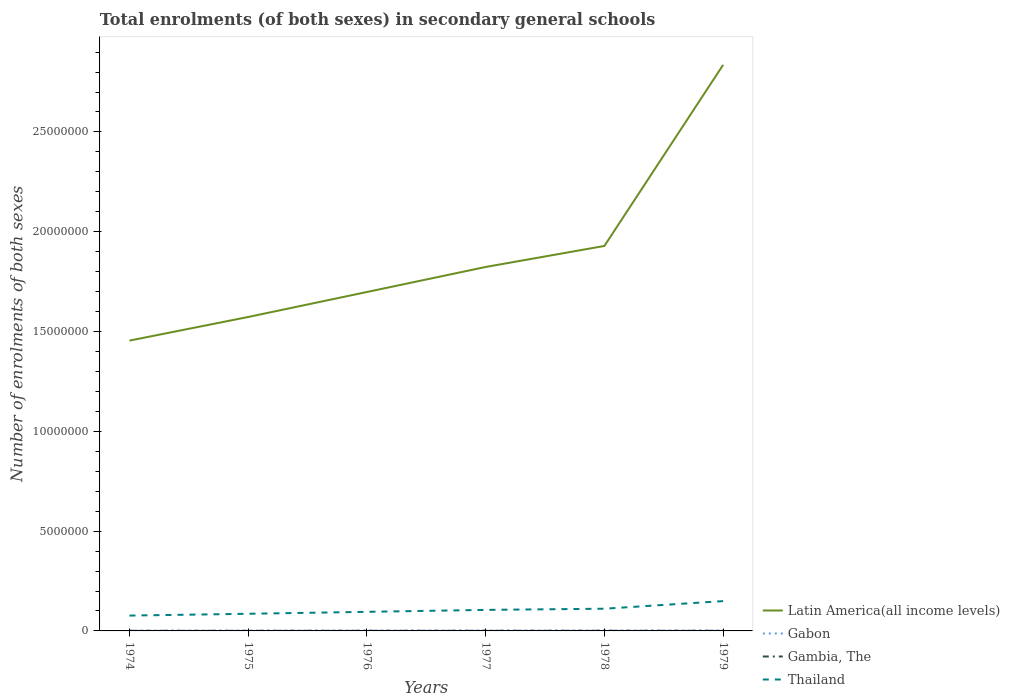Does the line corresponding to Gambia, The intersect with the line corresponding to Thailand?
Ensure brevity in your answer.  No. Is the number of lines equal to the number of legend labels?
Your answer should be compact. Yes. Across all years, what is the maximum number of enrolments in secondary schools in Gabon?
Make the answer very short. 1.45e+04. In which year was the number of enrolments in secondary schools in Gambia, The maximum?
Ensure brevity in your answer.  1974. What is the total number of enrolments in secondary schools in Thailand in the graph?
Your answer should be compact. -3.44e+05. What is the difference between the highest and the second highest number of enrolments in secondary schools in Gambia, The?
Your answer should be compact. 1870. How many lines are there?
Keep it short and to the point. 4. How many years are there in the graph?
Provide a succinct answer. 6. Are the values on the major ticks of Y-axis written in scientific E-notation?
Offer a very short reply. No. Does the graph contain grids?
Offer a terse response. No. Where does the legend appear in the graph?
Offer a terse response. Bottom right. How are the legend labels stacked?
Your response must be concise. Vertical. What is the title of the graph?
Offer a very short reply. Total enrolments (of both sexes) in secondary general schools. Does "Heavily indebted poor countries" appear as one of the legend labels in the graph?
Ensure brevity in your answer.  No. What is the label or title of the Y-axis?
Ensure brevity in your answer.  Number of enrolments of both sexes. What is the Number of enrolments of both sexes in Latin America(all income levels) in 1974?
Give a very brief answer. 1.45e+07. What is the Number of enrolments of both sexes in Gabon in 1974?
Keep it short and to the point. 1.45e+04. What is the Number of enrolments of both sexes of Gambia, The in 1974?
Provide a succinct answer. 5614. What is the Number of enrolments of both sexes of Thailand in 1974?
Ensure brevity in your answer.  7.69e+05. What is the Number of enrolments of both sexes of Latin America(all income levels) in 1975?
Offer a very short reply. 1.57e+07. What is the Number of enrolments of both sexes of Gabon in 1975?
Provide a succinct answer. 1.76e+04. What is the Number of enrolments of both sexes of Gambia, The in 1975?
Keep it short and to the point. 5791. What is the Number of enrolments of both sexes in Thailand in 1975?
Offer a very short reply. 8.59e+05. What is the Number of enrolments of both sexes in Latin America(all income levels) in 1976?
Give a very brief answer. 1.70e+07. What is the Number of enrolments of both sexes in Gabon in 1976?
Provide a succinct answer. 1.97e+04. What is the Number of enrolments of both sexes of Gambia, The in 1976?
Provide a short and direct response. 6178. What is the Number of enrolments of both sexes of Thailand in 1976?
Make the answer very short. 9.56e+05. What is the Number of enrolments of both sexes in Latin America(all income levels) in 1977?
Ensure brevity in your answer.  1.82e+07. What is the Number of enrolments of both sexes in Gabon in 1977?
Keep it short and to the point. 2.04e+04. What is the Number of enrolments of both sexes in Gambia, The in 1977?
Ensure brevity in your answer.  6834. What is the Number of enrolments of both sexes of Thailand in 1977?
Give a very brief answer. 1.05e+06. What is the Number of enrolments of both sexes in Latin America(all income levels) in 1978?
Your response must be concise. 1.93e+07. What is the Number of enrolments of both sexes of Gabon in 1978?
Provide a short and direct response. 2.16e+04. What is the Number of enrolments of both sexes of Gambia, The in 1978?
Make the answer very short. 6994. What is the Number of enrolments of both sexes of Thailand in 1978?
Ensure brevity in your answer.  1.11e+06. What is the Number of enrolments of both sexes of Latin America(all income levels) in 1979?
Make the answer very short. 2.84e+07. What is the Number of enrolments of both sexes in Gabon in 1979?
Keep it short and to the point. 2.03e+04. What is the Number of enrolments of both sexes of Gambia, The in 1979?
Provide a short and direct response. 7484. What is the Number of enrolments of both sexes in Thailand in 1979?
Offer a very short reply. 1.49e+06. Across all years, what is the maximum Number of enrolments of both sexes in Latin America(all income levels)?
Provide a short and direct response. 2.84e+07. Across all years, what is the maximum Number of enrolments of both sexes in Gabon?
Your answer should be compact. 2.16e+04. Across all years, what is the maximum Number of enrolments of both sexes of Gambia, The?
Your answer should be very brief. 7484. Across all years, what is the maximum Number of enrolments of both sexes in Thailand?
Your answer should be very brief. 1.49e+06. Across all years, what is the minimum Number of enrolments of both sexes in Latin America(all income levels)?
Ensure brevity in your answer.  1.45e+07. Across all years, what is the minimum Number of enrolments of both sexes in Gabon?
Ensure brevity in your answer.  1.45e+04. Across all years, what is the minimum Number of enrolments of both sexes of Gambia, The?
Keep it short and to the point. 5614. Across all years, what is the minimum Number of enrolments of both sexes in Thailand?
Keep it short and to the point. 7.69e+05. What is the total Number of enrolments of both sexes of Latin America(all income levels) in the graph?
Your answer should be very brief. 1.13e+08. What is the total Number of enrolments of both sexes in Gabon in the graph?
Your response must be concise. 1.14e+05. What is the total Number of enrolments of both sexes in Gambia, The in the graph?
Keep it short and to the point. 3.89e+04. What is the total Number of enrolments of both sexes of Thailand in the graph?
Your answer should be compact. 6.24e+06. What is the difference between the Number of enrolments of both sexes in Latin America(all income levels) in 1974 and that in 1975?
Provide a short and direct response. -1.18e+06. What is the difference between the Number of enrolments of both sexes of Gabon in 1974 and that in 1975?
Keep it short and to the point. -3085. What is the difference between the Number of enrolments of both sexes of Gambia, The in 1974 and that in 1975?
Your response must be concise. -177. What is the difference between the Number of enrolments of both sexes in Thailand in 1974 and that in 1975?
Your response must be concise. -9.01e+04. What is the difference between the Number of enrolments of both sexes of Latin America(all income levels) in 1974 and that in 1976?
Provide a succinct answer. -2.44e+06. What is the difference between the Number of enrolments of both sexes of Gabon in 1974 and that in 1976?
Ensure brevity in your answer.  -5231. What is the difference between the Number of enrolments of both sexes of Gambia, The in 1974 and that in 1976?
Keep it short and to the point. -564. What is the difference between the Number of enrolments of both sexes in Thailand in 1974 and that in 1976?
Keep it short and to the point. -1.88e+05. What is the difference between the Number of enrolments of both sexes in Latin America(all income levels) in 1974 and that in 1977?
Your answer should be very brief. -3.69e+06. What is the difference between the Number of enrolments of both sexes of Gabon in 1974 and that in 1977?
Provide a succinct answer. -5877. What is the difference between the Number of enrolments of both sexes of Gambia, The in 1974 and that in 1977?
Your answer should be very brief. -1220. What is the difference between the Number of enrolments of both sexes in Thailand in 1974 and that in 1977?
Your answer should be very brief. -2.85e+05. What is the difference between the Number of enrolments of both sexes in Latin America(all income levels) in 1974 and that in 1978?
Your answer should be very brief. -4.74e+06. What is the difference between the Number of enrolments of both sexes of Gabon in 1974 and that in 1978?
Provide a succinct answer. -7124. What is the difference between the Number of enrolments of both sexes of Gambia, The in 1974 and that in 1978?
Offer a terse response. -1380. What is the difference between the Number of enrolments of both sexes of Thailand in 1974 and that in 1978?
Ensure brevity in your answer.  -3.44e+05. What is the difference between the Number of enrolments of both sexes in Latin America(all income levels) in 1974 and that in 1979?
Offer a terse response. -1.38e+07. What is the difference between the Number of enrolments of both sexes of Gabon in 1974 and that in 1979?
Give a very brief answer. -5854. What is the difference between the Number of enrolments of both sexes in Gambia, The in 1974 and that in 1979?
Offer a terse response. -1870. What is the difference between the Number of enrolments of both sexes of Thailand in 1974 and that in 1979?
Your answer should be compact. -7.25e+05. What is the difference between the Number of enrolments of both sexes in Latin America(all income levels) in 1975 and that in 1976?
Your answer should be compact. -1.25e+06. What is the difference between the Number of enrolments of both sexes of Gabon in 1975 and that in 1976?
Provide a succinct answer. -2146. What is the difference between the Number of enrolments of both sexes of Gambia, The in 1975 and that in 1976?
Your response must be concise. -387. What is the difference between the Number of enrolments of both sexes of Thailand in 1975 and that in 1976?
Ensure brevity in your answer.  -9.75e+04. What is the difference between the Number of enrolments of both sexes of Latin America(all income levels) in 1975 and that in 1977?
Provide a succinct answer. -2.51e+06. What is the difference between the Number of enrolments of both sexes of Gabon in 1975 and that in 1977?
Your answer should be very brief. -2792. What is the difference between the Number of enrolments of both sexes in Gambia, The in 1975 and that in 1977?
Your answer should be very brief. -1043. What is the difference between the Number of enrolments of both sexes in Thailand in 1975 and that in 1977?
Provide a short and direct response. -1.95e+05. What is the difference between the Number of enrolments of both sexes of Latin America(all income levels) in 1975 and that in 1978?
Keep it short and to the point. -3.56e+06. What is the difference between the Number of enrolments of both sexes of Gabon in 1975 and that in 1978?
Your response must be concise. -4039. What is the difference between the Number of enrolments of both sexes in Gambia, The in 1975 and that in 1978?
Your answer should be compact. -1203. What is the difference between the Number of enrolments of both sexes in Thailand in 1975 and that in 1978?
Give a very brief answer. -2.54e+05. What is the difference between the Number of enrolments of both sexes in Latin America(all income levels) in 1975 and that in 1979?
Ensure brevity in your answer.  -1.26e+07. What is the difference between the Number of enrolments of both sexes of Gabon in 1975 and that in 1979?
Offer a very short reply. -2769. What is the difference between the Number of enrolments of both sexes of Gambia, The in 1975 and that in 1979?
Offer a terse response. -1693. What is the difference between the Number of enrolments of both sexes in Thailand in 1975 and that in 1979?
Offer a very short reply. -6.35e+05. What is the difference between the Number of enrolments of both sexes of Latin America(all income levels) in 1976 and that in 1977?
Provide a succinct answer. -1.25e+06. What is the difference between the Number of enrolments of both sexes in Gabon in 1976 and that in 1977?
Offer a very short reply. -646. What is the difference between the Number of enrolments of both sexes of Gambia, The in 1976 and that in 1977?
Provide a short and direct response. -656. What is the difference between the Number of enrolments of both sexes of Thailand in 1976 and that in 1977?
Provide a short and direct response. -9.72e+04. What is the difference between the Number of enrolments of both sexes in Latin America(all income levels) in 1976 and that in 1978?
Your answer should be compact. -2.31e+06. What is the difference between the Number of enrolments of both sexes in Gabon in 1976 and that in 1978?
Keep it short and to the point. -1893. What is the difference between the Number of enrolments of both sexes of Gambia, The in 1976 and that in 1978?
Give a very brief answer. -816. What is the difference between the Number of enrolments of both sexes of Thailand in 1976 and that in 1978?
Offer a terse response. -1.56e+05. What is the difference between the Number of enrolments of both sexes in Latin America(all income levels) in 1976 and that in 1979?
Make the answer very short. -1.14e+07. What is the difference between the Number of enrolments of both sexes in Gabon in 1976 and that in 1979?
Offer a terse response. -623. What is the difference between the Number of enrolments of both sexes of Gambia, The in 1976 and that in 1979?
Offer a very short reply. -1306. What is the difference between the Number of enrolments of both sexes in Thailand in 1976 and that in 1979?
Offer a very short reply. -5.37e+05. What is the difference between the Number of enrolments of both sexes of Latin America(all income levels) in 1977 and that in 1978?
Your response must be concise. -1.05e+06. What is the difference between the Number of enrolments of both sexes of Gabon in 1977 and that in 1978?
Offer a very short reply. -1247. What is the difference between the Number of enrolments of both sexes of Gambia, The in 1977 and that in 1978?
Your response must be concise. -160. What is the difference between the Number of enrolments of both sexes in Thailand in 1977 and that in 1978?
Provide a short and direct response. -5.89e+04. What is the difference between the Number of enrolments of both sexes of Latin America(all income levels) in 1977 and that in 1979?
Make the answer very short. -1.01e+07. What is the difference between the Number of enrolments of both sexes in Gabon in 1977 and that in 1979?
Your answer should be very brief. 23. What is the difference between the Number of enrolments of both sexes in Gambia, The in 1977 and that in 1979?
Offer a very short reply. -650. What is the difference between the Number of enrolments of both sexes in Thailand in 1977 and that in 1979?
Your answer should be compact. -4.40e+05. What is the difference between the Number of enrolments of both sexes of Latin America(all income levels) in 1978 and that in 1979?
Offer a very short reply. -9.07e+06. What is the difference between the Number of enrolments of both sexes of Gabon in 1978 and that in 1979?
Give a very brief answer. 1270. What is the difference between the Number of enrolments of both sexes of Gambia, The in 1978 and that in 1979?
Give a very brief answer. -490. What is the difference between the Number of enrolments of both sexes in Thailand in 1978 and that in 1979?
Your answer should be very brief. -3.81e+05. What is the difference between the Number of enrolments of both sexes of Latin America(all income levels) in 1974 and the Number of enrolments of both sexes of Gabon in 1975?
Make the answer very short. 1.45e+07. What is the difference between the Number of enrolments of both sexes of Latin America(all income levels) in 1974 and the Number of enrolments of both sexes of Gambia, The in 1975?
Your answer should be compact. 1.45e+07. What is the difference between the Number of enrolments of both sexes in Latin America(all income levels) in 1974 and the Number of enrolments of both sexes in Thailand in 1975?
Your answer should be very brief. 1.37e+07. What is the difference between the Number of enrolments of both sexes in Gabon in 1974 and the Number of enrolments of both sexes in Gambia, The in 1975?
Provide a short and direct response. 8699. What is the difference between the Number of enrolments of both sexes of Gabon in 1974 and the Number of enrolments of both sexes of Thailand in 1975?
Your answer should be compact. -8.44e+05. What is the difference between the Number of enrolments of both sexes in Gambia, The in 1974 and the Number of enrolments of both sexes in Thailand in 1975?
Your answer should be very brief. -8.53e+05. What is the difference between the Number of enrolments of both sexes of Latin America(all income levels) in 1974 and the Number of enrolments of both sexes of Gabon in 1976?
Your answer should be very brief. 1.45e+07. What is the difference between the Number of enrolments of both sexes in Latin America(all income levels) in 1974 and the Number of enrolments of both sexes in Gambia, The in 1976?
Your response must be concise. 1.45e+07. What is the difference between the Number of enrolments of both sexes of Latin America(all income levels) in 1974 and the Number of enrolments of both sexes of Thailand in 1976?
Your answer should be very brief. 1.36e+07. What is the difference between the Number of enrolments of both sexes of Gabon in 1974 and the Number of enrolments of both sexes of Gambia, The in 1976?
Offer a very short reply. 8312. What is the difference between the Number of enrolments of both sexes in Gabon in 1974 and the Number of enrolments of both sexes in Thailand in 1976?
Provide a succinct answer. -9.42e+05. What is the difference between the Number of enrolments of both sexes of Gambia, The in 1974 and the Number of enrolments of both sexes of Thailand in 1976?
Provide a succinct answer. -9.51e+05. What is the difference between the Number of enrolments of both sexes in Latin America(all income levels) in 1974 and the Number of enrolments of both sexes in Gabon in 1977?
Make the answer very short. 1.45e+07. What is the difference between the Number of enrolments of both sexes in Latin America(all income levels) in 1974 and the Number of enrolments of both sexes in Gambia, The in 1977?
Provide a succinct answer. 1.45e+07. What is the difference between the Number of enrolments of both sexes of Latin America(all income levels) in 1974 and the Number of enrolments of both sexes of Thailand in 1977?
Provide a succinct answer. 1.35e+07. What is the difference between the Number of enrolments of both sexes in Gabon in 1974 and the Number of enrolments of both sexes in Gambia, The in 1977?
Give a very brief answer. 7656. What is the difference between the Number of enrolments of both sexes of Gabon in 1974 and the Number of enrolments of both sexes of Thailand in 1977?
Your response must be concise. -1.04e+06. What is the difference between the Number of enrolments of both sexes of Gambia, The in 1974 and the Number of enrolments of both sexes of Thailand in 1977?
Keep it short and to the point. -1.05e+06. What is the difference between the Number of enrolments of both sexes in Latin America(all income levels) in 1974 and the Number of enrolments of both sexes in Gabon in 1978?
Offer a terse response. 1.45e+07. What is the difference between the Number of enrolments of both sexes in Latin America(all income levels) in 1974 and the Number of enrolments of both sexes in Gambia, The in 1978?
Your response must be concise. 1.45e+07. What is the difference between the Number of enrolments of both sexes of Latin America(all income levels) in 1974 and the Number of enrolments of both sexes of Thailand in 1978?
Offer a terse response. 1.34e+07. What is the difference between the Number of enrolments of both sexes in Gabon in 1974 and the Number of enrolments of both sexes in Gambia, The in 1978?
Provide a short and direct response. 7496. What is the difference between the Number of enrolments of both sexes in Gabon in 1974 and the Number of enrolments of both sexes in Thailand in 1978?
Ensure brevity in your answer.  -1.10e+06. What is the difference between the Number of enrolments of both sexes in Gambia, The in 1974 and the Number of enrolments of both sexes in Thailand in 1978?
Your answer should be very brief. -1.11e+06. What is the difference between the Number of enrolments of both sexes in Latin America(all income levels) in 1974 and the Number of enrolments of both sexes in Gabon in 1979?
Provide a short and direct response. 1.45e+07. What is the difference between the Number of enrolments of both sexes in Latin America(all income levels) in 1974 and the Number of enrolments of both sexes in Gambia, The in 1979?
Your answer should be compact. 1.45e+07. What is the difference between the Number of enrolments of both sexes of Latin America(all income levels) in 1974 and the Number of enrolments of both sexes of Thailand in 1979?
Provide a succinct answer. 1.31e+07. What is the difference between the Number of enrolments of both sexes in Gabon in 1974 and the Number of enrolments of both sexes in Gambia, The in 1979?
Offer a very short reply. 7006. What is the difference between the Number of enrolments of both sexes in Gabon in 1974 and the Number of enrolments of both sexes in Thailand in 1979?
Provide a succinct answer. -1.48e+06. What is the difference between the Number of enrolments of both sexes in Gambia, The in 1974 and the Number of enrolments of both sexes in Thailand in 1979?
Offer a terse response. -1.49e+06. What is the difference between the Number of enrolments of both sexes in Latin America(all income levels) in 1975 and the Number of enrolments of both sexes in Gabon in 1976?
Make the answer very short. 1.57e+07. What is the difference between the Number of enrolments of both sexes in Latin America(all income levels) in 1975 and the Number of enrolments of both sexes in Gambia, The in 1976?
Your answer should be very brief. 1.57e+07. What is the difference between the Number of enrolments of both sexes in Latin America(all income levels) in 1975 and the Number of enrolments of both sexes in Thailand in 1976?
Your answer should be very brief. 1.48e+07. What is the difference between the Number of enrolments of both sexes of Gabon in 1975 and the Number of enrolments of both sexes of Gambia, The in 1976?
Provide a short and direct response. 1.14e+04. What is the difference between the Number of enrolments of both sexes of Gabon in 1975 and the Number of enrolments of both sexes of Thailand in 1976?
Keep it short and to the point. -9.39e+05. What is the difference between the Number of enrolments of both sexes of Gambia, The in 1975 and the Number of enrolments of both sexes of Thailand in 1976?
Make the answer very short. -9.51e+05. What is the difference between the Number of enrolments of both sexes in Latin America(all income levels) in 1975 and the Number of enrolments of both sexes in Gabon in 1977?
Give a very brief answer. 1.57e+07. What is the difference between the Number of enrolments of both sexes in Latin America(all income levels) in 1975 and the Number of enrolments of both sexes in Gambia, The in 1977?
Provide a short and direct response. 1.57e+07. What is the difference between the Number of enrolments of both sexes of Latin America(all income levels) in 1975 and the Number of enrolments of both sexes of Thailand in 1977?
Make the answer very short. 1.47e+07. What is the difference between the Number of enrolments of both sexes of Gabon in 1975 and the Number of enrolments of both sexes of Gambia, The in 1977?
Your answer should be very brief. 1.07e+04. What is the difference between the Number of enrolments of both sexes of Gabon in 1975 and the Number of enrolments of both sexes of Thailand in 1977?
Make the answer very short. -1.04e+06. What is the difference between the Number of enrolments of both sexes in Gambia, The in 1975 and the Number of enrolments of both sexes in Thailand in 1977?
Your answer should be compact. -1.05e+06. What is the difference between the Number of enrolments of both sexes in Latin America(all income levels) in 1975 and the Number of enrolments of both sexes in Gabon in 1978?
Your response must be concise. 1.57e+07. What is the difference between the Number of enrolments of both sexes in Latin America(all income levels) in 1975 and the Number of enrolments of both sexes in Gambia, The in 1978?
Offer a terse response. 1.57e+07. What is the difference between the Number of enrolments of both sexes of Latin America(all income levels) in 1975 and the Number of enrolments of both sexes of Thailand in 1978?
Your answer should be compact. 1.46e+07. What is the difference between the Number of enrolments of both sexes in Gabon in 1975 and the Number of enrolments of both sexes in Gambia, The in 1978?
Your answer should be very brief. 1.06e+04. What is the difference between the Number of enrolments of both sexes in Gabon in 1975 and the Number of enrolments of both sexes in Thailand in 1978?
Your answer should be very brief. -1.09e+06. What is the difference between the Number of enrolments of both sexes in Gambia, The in 1975 and the Number of enrolments of both sexes in Thailand in 1978?
Your response must be concise. -1.11e+06. What is the difference between the Number of enrolments of both sexes of Latin America(all income levels) in 1975 and the Number of enrolments of both sexes of Gabon in 1979?
Ensure brevity in your answer.  1.57e+07. What is the difference between the Number of enrolments of both sexes of Latin America(all income levels) in 1975 and the Number of enrolments of both sexes of Gambia, The in 1979?
Keep it short and to the point. 1.57e+07. What is the difference between the Number of enrolments of both sexes of Latin America(all income levels) in 1975 and the Number of enrolments of both sexes of Thailand in 1979?
Offer a terse response. 1.42e+07. What is the difference between the Number of enrolments of both sexes of Gabon in 1975 and the Number of enrolments of both sexes of Gambia, The in 1979?
Provide a short and direct response. 1.01e+04. What is the difference between the Number of enrolments of both sexes in Gabon in 1975 and the Number of enrolments of both sexes in Thailand in 1979?
Provide a short and direct response. -1.48e+06. What is the difference between the Number of enrolments of both sexes of Gambia, The in 1975 and the Number of enrolments of both sexes of Thailand in 1979?
Ensure brevity in your answer.  -1.49e+06. What is the difference between the Number of enrolments of both sexes of Latin America(all income levels) in 1976 and the Number of enrolments of both sexes of Gabon in 1977?
Keep it short and to the point. 1.70e+07. What is the difference between the Number of enrolments of both sexes in Latin America(all income levels) in 1976 and the Number of enrolments of both sexes in Gambia, The in 1977?
Offer a terse response. 1.70e+07. What is the difference between the Number of enrolments of both sexes in Latin America(all income levels) in 1976 and the Number of enrolments of both sexes in Thailand in 1977?
Ensure brevity in your answer.  1.59e+07. What is the difference between the Number of enrolments of both sexes in Gabon in 1976 and the Number of enrolments of both sexes in Gambia, The in 1977?
Provide a short and direct response. 1.29e+04. What is the difference between the Number of enrolments of both sexes in Gabon in 1976 and the Number of enrolments of both sexes in Thailand in 1977?
Ensure brevity in your answer.  -1.03e+06. What is the difference between the Number of enrolments of both sexes of Gambia, The in 1976 and the Number of enrolments of both sexes of Thailand in 1977?
Make the answer very short. -1.05e+06. What is the difference between the Number of enrolments of both sexes in Latin America(all income levels) in 1976 and the Number of enrolments of both sexes in Gabon in 1978?
Your answer should be very brief. 1.70e+07. What is the difference between the Number of enrolments of both sexes in Latin America(all income levels) in 1976 and the Number of enrolments of both sexes in Gambia, The in 1978?
Keep it short and to the point. 1.70e+07. What is the difference between the Number of enrolments of both sexes in Latin America(all income levels) in 1976 and the Number of enrolments of both sexes in Thailand in 1978?
Offer a terse response. 1.59e+07. What is the difference between the Number of enrolments of both sexes in Gabon in 1976 and the Number of enrolments of both sexes in Gambia, The in 1978?
Keep it short and to the point. 1.27e+04. What is the difference between the Number of enrolments of both sexes of Gabon in 1976 and the Number of enrolments of both sexes of Thailand in 1978?
Your answer should be very brief. -1.09e+06. What is the difference between the Number of enrolments of both sexes in Gambia, The in 1976 and the Number of enrolments of both sexes in Thailand in 1978?
Provide a succinct answer. -1.11e+06. What is the difference between the Number of enrolments of both sexes of Latin America(all income levels) in 1976 and the Number of enrolments of both sexes of Gabon in 1979?
Your response must be concise. 1.70e+07. What is the difference between the Number of enrolments of both sexes in Latin America(all income levels) in 1976 and the Number of enrolments of both sexes in Gambia, The in 1979?
Give a very brief answer. 1.70e+07. What is the difference between the Number of enrolments of both sexes in Latin America(all income levels) in 1976 and the Number of enrolments of both sexes in Thailand in 1979?
Keep it short and to the point. 1.55e+07. What is the difference between the Number of enrolments of both sexes in Gabon in 1976 and the Number of enrolments of both sexes in Gambia, The in 1979?
Offer a terse response. 1.22e+04. What is the difference between the Number of enrolments of both sexes in Gabon in 1976 and the Number of enrolments of both sexes in Thailand in 1979?
Provide a short and direct response. -1.47e+06. What is the difference between the Number of enrolments of both sexes of Gambia, The in 1976 and the Number of enrolments of both sexes of Thailand in 1979?
Your answer should be compact. -1.49e+06. What is the difference between the Number of enrolments of both sexes of Latin America(all income levels) in 1977 and the Number of enrolments of both sexes of Gabon in 1978?
Provide a short and direct response. 1.82e+07. What is the difference between the Number of enrolments of both sexes in Latin America(all income levels) in 1977 and the Number of enrolments of both sexes in Gambia, The in 1978?
Your answer should be compact. 1.82e+07. What is the difference between the Number of enrolments of both sexes in Latin America(all income levels) in 1977 and the Number of enrolments of both sexes in Thailand in 1978?
Your answer should be compact. 1.71e+07. What is the difference between the Number of enrolments of both sexes in Gabon in 1977 and the Number of enrolments of both sexes in Gambia, The in 1978?
Ensure brevity in your answer.  1.34e+04. What is the difference between the Number of enrolments of both sexes in Gabon in 1977 and the Number of enrolments of both sexes in Thailand in 1978?
Offer a very short reply. -1.09e+06. What is the difference between the Number of enrolments of both sexes in Gambia, The in 1977 and the Number of enrolments of both sexes in Thailand in 1978?
Offer a very short reply. -1.11e+06. What is the difference between the Number of enrolments of both sexes in Latin America(all income levels) in 1977 and the Number of enrolments of both sexes in Gabon in 1979?
Keep it short and to the point. 1.82e+07. What is the difference between the Number of enrolments of both sexes of Latin America(all income levels) in 1977 and the Number of enrolments of both sexes of Gambia, The in 1979?
Your response must be concise. 1.82e+07. What is the difference between the Number of enrolments of both sexes in Latin America(all income levels) in 1977 and the Number of enrolments of both sexes in Thailand in 1979?
Ensure brevity in your answer.  1.67e+07. What is the difference between the Number of enrolments of both sexes of Gabon in 1977 and the Number of enrolments of both sexes of Gambia, The in 1979?
Provide a succinct answer. 1.29e+04. What is the difference between the Number of enrolments of both sexes of Gabon in 1977 and the Number of enrolments of both sexes of Thailand in 1979?
Give a very brief answer. -1.47e+06. What is the difference between the Number of enrolments of both sexes in Gambia, The in 1977 and the Number of enrolments of both sexes in Thailand in 1979?
Give a very brief answer. -1.49e+06. What is the difference between the Number of enrolments of both sexes in Latin America(all income levels) in 1978 and the Number of enrolments of both sexes in Gabon in 1979?
Your answer should be very brief. 1.93e+07. What is the difference between the Number of enrolments of both sexes in Latin America(all income levels) in 1978 and the Number of enrolments of both sexes in Gambia, The in 1979?
Ensure brevity in your answer.  1.93e+07. What is the difference between the Number of enrolments of both sexes in Latin America(all income levels) in 1978 and the Number of enrolments of both sexes in Thailand in 1979?
Your answer should be compact. 1.78e+07. What is the difference between the Number of enrolments of both sexes in Gabon in 1978 and the Number of enrolments of both sexes in Gambia, The in 1979?
Make the answer very short. 1.41e+04. What is the difference between the Number of enrolments of both sexes of Gabon in 1978 and the Number of enrolments of both sexes of Thailand in 1979?
Your response must be concise. -1.47e+06. What is the difference between the Number of enrolments of both sexes in Gambia, The in 1978 and the Number of enrolments of both sexes in Thailand in 1979?
Offer a terse response. -1.49e+06. What is the average Number of enrolments of both sexes in Latin America(all income levels) per year?
Your answer should be very brief. 1.89e+07. What is the average Number of enrolments of both sexes of Gabon per year?
Make the answer very short. 1.90e+04. What is the average Number of enrolments of both sexes of Gambia, The per year?
Provide a succinct answer. 6482.5. What is the average Number of enrolments of both sexes of Thailand per year?
Keep it short and to the point. 1.04e+06. In the year 1974, what is the difference between the Number of enrolments of both sexes of Latin America(all income levels) and Number of enrolments of both sexes of Gabon?
Your answer should be compact. 1.45e+07. In the year 1974, what is the difference between the Number of enrolments of both sexes of Latin America(all income levels) and Number of enrolments of both sexes of Gambia, The?
Provide a short and direct response. 1.45e+07. In the year 1974, what is the difference between the Number of enrolments of both sexes in Latin America(all income levels) and Number of enrolments of both sexes in Thailand?
Give a very brief answer. 1.38e+07. In the year 1974, what is the difference between the Number of enrolments of both sexes of Gabon and Number of enrolments of both sexes of Gambia, The?
Provide a succinct answer. 8876. In the year 1974, what is the difference between the Number of enrolments of both sexes in Gabon and Number of enrolments of both sexes in Thailand?
Provide a succinct answer. -7.54e+05. In the year 1974, what is the difference between the Number of enrolments of both sexes in Gambia, The and Number of enrolments of both sexes in Thailand?
Provide a succinct answer. -7.63e+05. In the year 1975, what is the difference between the Number of enrolments of both sexes of Latin America(all income levels) and Number of enrolments of both sexes of Gabon?
Your answer should be very brief. 1.57e+07. In the year 1975, what is the difference between the Number of enrolments of both sexes in Latin America(all income levels) and Number of enrolments of both sexes in Gambia, The?
Keep it short and to the point. 1.57e+07. In the year 1975, what is the difference between the Number of enrolments of both sexes of Latin America(all income levels) and Number of enrolments of both sexes of Thailand?
Provide a succinct answer. 1.49e+07. In the year 1975, what is the difference between the Number of enrolments of both sexes of Gabon and Number of enrolments of both sexes of Gambia, The?
Make the answer very short. 1.18e+04. In the year 1975, what is the difference between the Number of enrolments of both sexes of Gabon and Number of enrolments of both sexes of Thailand?
Offer a very short reply. -8.41e+05. In the year 1975, what is the difference between the Number of enrolments of both sexes of Gambia, The and Number of enrolments of both sexes of Thailand?
Make the answer very short. -8.53e+05. In the year 1976, what is the difference between the Number of enrolments of both sexes in Latin America(all income levels) and Number of enrolments of both sexes in Gabon?
Your answer should be very brief. 1.70e+07. In the year 1976, what is the difference between the Number of enrolments of both sexes in Latin America(all income levels) and Number of enrolments of both sexes in Gambia, The?
Ensure brevity in your answer.  1.70e+07. In the year 1976, what is the difference between the Number of enrolments of both sexes in Latin America(all income levels) and Number of enrolments of both sexes in Thailand?
Your answer should be very brief. 1.60e+07. In the year 1976, what is the difference between the Number of enrolments of both sexes in Gabon and Number of enrolments of both sexes in Gambia, The?
Provide a short and direct response. 1.35e+04. In the year 1976, what is the difference between the Number of enrolments of both sexes of Gabon and Number of enrolments of both sexes of Thailand?
Your response must be concise. -9.37e+05. In the year 1976, what is the difference between the Number of enrolments of both sexes of Gambia, The and Number of enrolments of both sexes of Thailand?
Your answer should be compact. -9.50e+05. In the year 1977, what is the difference between the Number of enrolments of both sexes in Latin America(all income levels) and Number of enrolments of both sexes in Gabon?
Your response must be concise. 1.82e+07. In the year 1977, what is the difference between the Number of enrolments of both sexes of Latin America(all income levels) and Number of enrolments of both sexes of Gambia, The?
Keep it short and to the point. 1.82e+07. In the year 1977, what is the difference between the Number of enrolments of both sexes in Latin America(all income levels) and Number of enrolments of both sexes in Thailand?
Ensure brevity in your answer.  1.72e+07. In the year 1977, what is the difference between the Number of enrolments of both sexes in Gabon and Number of enrolments of both sexes in Gambia, The?
Keep it short and to the point. 1.35e+04. In the year 1977, what is the difference between the Number of enrolments of both sexes of Gabon and Number of enrolments of both sexes of Thailand?
Offer a terse response. -1.03e+06. In the year 1977, what is the difference between the Number of enrolments of both sexes of Gambia, The and Number of enrolments of both sexes of Thailand?
Keep it short and to the point. -1.05e+06. In the year 1978, what is the difference between the Number of enrolments of both sexes of Latin America(all income levels) and Number of enrolments of both sexes of Gabon?
Provide a short and direct response. 1.93e+07. In the year 1978, what is the difference between the Number of enrolments of both sexes of Latin America(all income levels) and Number of enrolments of both sexes of Gambia, The?
Your response must be concise. 1.93e+07. In the year 1978, what is the difference between the Number of enrolments of both sexes of Latin America(all income levels) and Number of enrolments of both sexes of Thailand?
Offer a very short reply. 1.82e+07. In the year 1978, what is the difference between the Number of enrolments of both sexes in Gabon and Number of enrolments of both sexes in Gambia, The?
Give a very brief answer. 1.46e+04. In the year 1978, what is the difference between the Number of enrolments of both sexes of Gabon and Number of enrolments of both sexes of Thailand?
Your response must be concise. -1.09e+06. In the year 1978, what is the difference between the Number of enrolments of both sexes in Gambia, The and Number of enrolments of both sexes in Thailand?
Keep it short and to the point. -1.11e+06. In the year 1979, what is the difference between the Number of enrolments of both sexes in Latin America(all income levels) and Number of enrolments of both sexes in Gabon?
Offer a terse response. 2.83e+07. In the year 1979, what is the difference between the Number of enrolments of both sexes in Latin America(all income levels) and Number of enrolments of both sexes in Gambia, The?
Ensure brevity in your answer.  2.84e+07. In the year 1979, what is the difference between the Number of enrolments of both sexes in Latin America(all income levels) and Number of enrolments of both sexes in Thailand?
Make the answer very short. 2.69e+07. In the year 1979, what is the difference between the Number of enrolments of both sexes of Gabon and Number of enrolments of both sexes of Gambia, The?
Ensure brevity in your answer.  1.29e+04. In the year 1979, what is the difference between the Number of enrolments of both sexes in Gabon and Number of enrolments of both sexes in Thailand?
Offer a terse response. -1.47e+06. In the year 1979, what is the difference between the Number of enrolments of both sexes in Gambia, The and Number of enrolments of both sexes in Thailand?
Provide a short and direct response. -1.49e+06. What is the ratio of the Number of enrolments of both sexes of Latin America(all income levels) in 1974 to that in 1975?
Give a very brief answer. 0.92. What is the ratio of the Number of enrolments of both sexes of Gabon in 1974 to that in 1975?
Your answer should be very brief. 0.82. What is the ratio of the Number of enrolments of both sexes in Gambia, The in 1974 to that in 1975?
Keep it short and to the point. 0.97. What is the ratio of the Number of enrolments of both sexes in Thailand in 1974 to that in 1975?
Your response must be concise. 0.9. What is the ratio of the Number of enrolments of both sexes of Latin America(all income levels) in 1974 to that in 1976?
Your answer should be compact. 0.86. What is the ratio of the Number of enrolments of both sexes of Gabon in 1974 to that in 1976?
Your answer should be very brief. 0.73. What is the ratio of the Number of enrolments of both sexes in Gambia, The in 1974 to that in 1976?
Provide a short and direct response. 0.91. What is the ratio of the Number of enrolments of both sexes in Thailand in 1974 to that in 1976?
Keep it short and to the point. 0.8. What is the ratio of the Number of enrolments of both sexes of Latin America(all income levels) in 1974 to that in 1977?
Your answer should be very brief. 0.8. What is the ratio of the Number of enrolments of both sexes in Gabon in 1974 to that in 1977?
Ensure brevity in your answer.  0.71. What is the ratio of the Number of enrolments of both sexes in Gambia, The in 1974 to that in 1977?
Provide a succinct answer. 0.82. What is the ratio of the Number of enrolments of both sexes in Thailand in 1974 to that in 1977?
Offer a terse response. 0.73. What is the ratio of the Number of enrolments of both sexes in Latin America(all income levels) in 1974 to that in 1978?
Provide a succinct answer. 0.75. What is the ratio of the Number of enrolments of both sexes of Gabon in 1974 to that in 1978?
Offer a terse response. 0.67. What is the ratio of the Number of enrolments of both sexes of Gambia, The in 1974 to that in 1978?
Your answer should be very brief. 0.8. What is the ratio of the Number of enrolments of both sexes in Thailand in 1974 to that in 1978?
Offer a terse response. 0.69. What is the ratio of the Number of enrolments of both sexes in Latin America(all income levels) in 1974 to that in 1979?
Give a very brief answer. 0.51. What is the ratio of the Number of enrolments of both sexes of Gabon in 1974 to that in 1979?
Ensure brevity in your answer.  0.71. What is the ratio of the Number of enrolments of both sexes in Gambia, The in 1974 to that in 1979?
Provide a short and direct response. 0.75. What is the ratio of the Number of enrolments of both sexes of Thailand in 1974 to that in 1979?
Give a very brief answer. 0.51. What is the ratio of the Number of enrolments of both sexes of Latin America(all income levels) in 1975 to that in 1976?
Give a very brief answer. 0.93. What is the ratio of the Number of enrolments of both sexes in Gabon in 1975 to that in 1976?
Provide a short and direct response. 0.89. What is the ratio of the Number of enrolments of both sexes in Gambia, The in 1975 to that in 1976?
Offer a terse response. 0.94. What is the ratio of the Number of enrolments of both sexes in Thailand in 1975 to that in 1976?
Provide a short and direct response. 0.9. What is the ratio of the Number of enrolments of both sexes in Latin America(all income levels) in 1975 to that in 1977?
Your answer should be very brief. 0.86. What is the ratio of the Number of enrolments of both sexes in Gabon in 1975 to that in 1977?
Make the answer very short. 0.86. What is the ratio of the Number of enrolments of both sexes in Gambia, The in 1975 to that in 1977?
Your answer should be very brief. 0.85. What is the ratio of the Number of enrolments of both sexes in Thailand in 1975 to that in 1977?
Your answer should be compact. 0.82. What is the ratio of the Number of enrolments of both sexes in Latin America(all income levels) in 1975 to that in 1978?
Make the answer very short. 0.82. What is the ratio of the Number of enrolments of both sexes in Gabon in 1975 to that in 1978?
Your answer should be compact. 0.81. What is the ratio of the Number of enrolments of both sexes in Gambia, The in 1975 to that in 1978?
Provide a short and direct response. 0.83. What is the ratio of the Number of enrolments of both sexes in Thailand in 1975 to that in 1978?
Your answer should be very brief. 0.77. What is the ratio of the Number of enrolments of both sexes in Latin America(all income levels) in 1975 to that in 1979?
Your answer should be compact. 0.55. What is the ratio of the Number of enrolments of both sexes of Gabon in 1975 to that in 1979?
Provide a succinct answer. 0.86. What is the ratio of the Number of enrolments of both sexes of Gambia, The in 1975 to that in 1979?
Provide a short and direct response. 0.77. What is the ratio of the Number of enrolments of both sexes in Thailand in 1975 to that in 1979?
Provide a short and direct response. 0.58. What is the ratio of the Number of enrolments of both sexes of Latin America(all income levels) in 1976 to that in 1977?
Keep it short and to the point. 0.93. What is the ratio of the Number of enrolments of both sexes of Gabon in 1976 to that in 1977?
Offer a terse response. 0.97. What is the ratio of the Number of enrolments of both sexes in Gambia, The in 1976 to that in 1977?
Keep it short and to the point. 0.9. What is the ratio of the Number of enrolments of both sexes in Thailand in 1976 to that in 1977?
Your response must be concise. 0.91. What is the ratio of the Number of enrolments of both sexes of Latin America(all income levels) in 1976 to that in 1978?
Your response must be concise. 0.88. What is the ratio of the Number of enrolments of both sexes in Gabon in 1976 to that in 1978?
Keep it short and to the point. 0.91. What is the ratio of the Number of enrolments of both sexes of Gambia, The in 1976 to that in 1978?
Ensure brevity in your answer.  0.88. What is the ratio of the Number of enrolments of both sexes of Thailand in 1976 to that in 1978?
Make the answer very short. 0.86. What is the ratio of the Number of enrolments of both sexes in Latin America(all income levels) in 1976 to that in 1979?
Make the answer very short. 0.6. What is the ratio of the Number of enrolments of both sexes in Gabon in 1976 to that in 1979?
Your answer should be compact. 0.97. What is the ratio of the Number of enrolments of both sexes in Gambia, The in 1976 to that in 1979?
Your answer should be compact. 0.83. What is the ratio of the Number of enrolments of both sexes of Thailand in 1976 to that in 1979?
Offer a very short reply. 0.64. What is the ratio of the Number of enrolments of both sexes in Latin America(all income levels) in 1977 to that in 1978?
Your answer should be very brief. 0.95. What is the ratio of the Number of enrolments of both sexes of Gabon in 1977 to that in 1978?
Offer a very short reply. 0.94. What is the ratio of the Number of enrolments of both sexes of Gambia, The in 1977 to that in 1978?
Provide a short and direct response. 0.98. What is the ratio of the Number of enrolments of both sexes in Thailand in 1977 to that in 1978?
Give a very brief answer. 0.95. What is the ratio of the Number of enrolments of both sexes of Latin America(all income levels) in 1977 to that in 1979?
Offer a very short reply. 0.64. What is the ratio of the Number of enrolments of both sexes of Gambia, The in 1977 to that in 1979?
Offer a terse response. 0.91. What is the ratio of the Number of enrolments of both sexes of Thailand in 1977 to that in 1979?
Offer a terse response. 0.71. What is the ratio of the Number of enrolments of both sexes in Latin America(all income levels) in 1978 to that in 1979?
Your answer should be very brief. 0.68. What is the ratio of the Number of enrolments of both sexes of Gabon in 1978 to that in 1979?
Ensure brevity in your answer.  1.06. What is the ratio of the Number of enrolments of both sexes in Gambia, The in 1978 to that in 1979?
Offer a terse response. 0.93. What is the ratio of the Number of enrolments of both sexes of Thailand in 1978 to that in 1979?
Provide a short and direct response. 0.74. What is the difference between the highest and the second highest Number of enrolments of both sexes in Latin America(all income levels)?
Your answer should be very brief. 9.07e+06. What is the difference between the highest and the second highest Number of enrolments of both sexes of Gabon?
Your answer should be very brief. 1247. What is the difference between the highest and the second highest Number of enrolments of both sexes of Gambia, The?
Your answer should be compact. 490. What is the difference between the highest and the second highest Number of enrolments of both sexes of Thailand?
Your answer should be compact. 3.81e+05. What is the difference between the highest and the lowest Number of enrolments of both sexes in Latin America(all income levels)?
Provide a short and direct response. 1.38e+07. What is the difference between the highest and the lowest Number of enrolments of both sexes in Gabon?
Give a very brief answer. 7124. What is the difference between the highest and the lowest Number of enrolments of both sexes of Gambia, The?
Offer a terse response. 1870. What is the difference between the highest and the lowest Number of enrolments of both sexes of Thailand?
Your answer should be compact. 7.25e+05. 